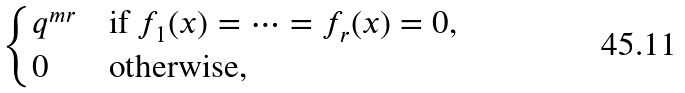<formula> <loc_0><loc_0><loc_500><loc_500>\begin{cases} q ^ { m r } & \text {if $f_{1}(x)=\cdots=f_{r}(x)=0$} , \\ 0 & \text {otherwise} , \end{cases}</formula> 